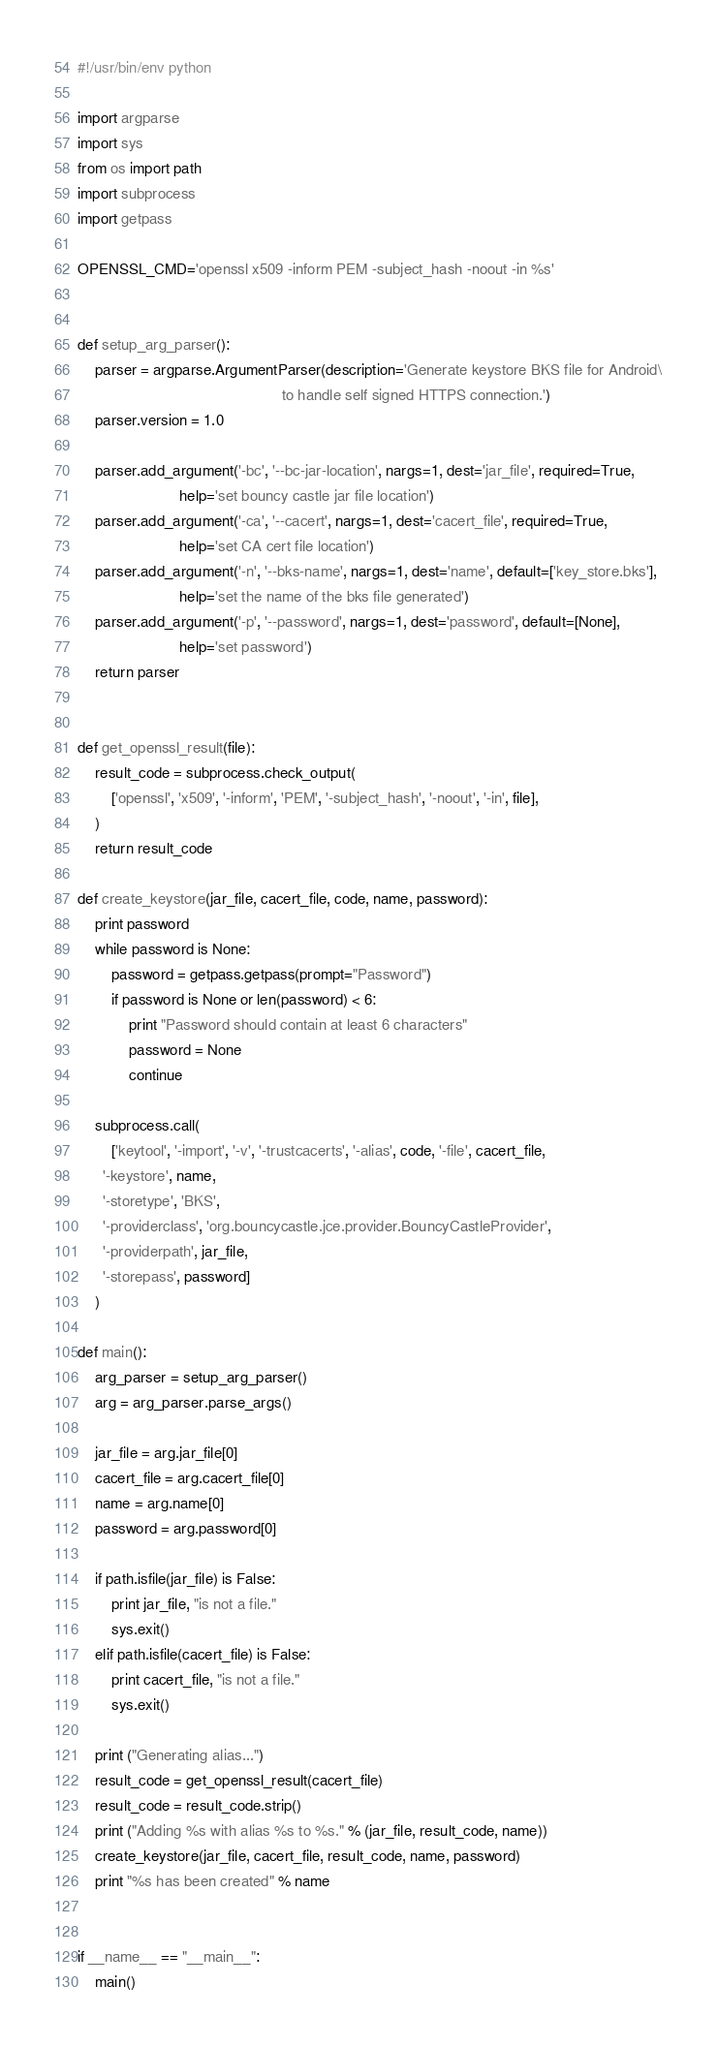Convert code to text. <code><loc_0><loc_0><loc_500><loc_500><_Python_>#!/usr/bin/env python

import argparse
import sys
from os import path
import subprocess
import getpass

OPENSSL_CMD='openssl x509 -inform PEM -subject_hash -noout -in %s'


def setup_arg_parser():
    parser = argparse.ArgumentParser(description='Generate keystore BKS file for Android\
                                                to handle self signed HTTPS connection.')
    parser.version = 1.0

    parser.add_argument('-bc', '--bc-jar-location', nargs=1, dest='jar_file', required=True,
                        help='set bouncy castle jar file location')
    parser.add_argument('-ca', '--cacert', nargs=1, dest='cacert_file', required=True,
                        help='set CA cert file location')
    parser.add_argument('-n', '--bks-name', nargs=1, dest='name', default=['key_store.bks'],
                        help='set the name of the bks file generated')
    parser.add_argument('-p', '--password', nargs=1, dest='password', default=[None],
                        help='set password')
    return parser


def get_openssl_result(file):
    result_code = subprocess.check_output(
        ['openssl', 'x509', '-inform', 'PEM', '-subject_hash', '-noout', '-in', file],
    )
    return result_code

def create_keystore(jar_file, cacert_file, code, name, password):
    print password
    while password is None:
        password = getpass.getpass(prompt="Password")
        if password is None or len(password) < 6:
            print "Password should contain at least 6 characters"
            password = None
            continue

    subprocess.call(
        ['keytool', '-import', '-v', '-trustcacerts', '-alias', code, '-file', cacert_file,
      '-keystore', name,
      '-storetype', 'BKS',
      '-providerclass', 'org.bouncycastle.jce.provider.BouncyCastleProvider',
      '-providerpath', jar_file,
      '-storepass', password]
    )

def main():
    arg_parser = setup_arg_parser()
    arg = arg_parser.parse_args()

    jar_file = arg.jar_file[0]
    cacert_file = arg.cacert_file[0]
    name = arg.name[0]
    password = arg.password[0]

    if path.isfile(jar_file) is False:
        print jar_file, "is not a file."
        sys.exit()
    elif path.isfile(cacert_file) is False:
        print cacert_file, "is not a file."
        sys.exit()

    print ("Generating alias...")
    result_code = get_openssl_result(cacert_file)
    result_code = result_code.strip()
    print ("Adding %s with alias %s to %s." % (jar_file, result_code, name))
    create_keystore(jar_file, cacert_file, result_code, name, password)
    print "%s has been created" % name


if __name__ == "__main__":
    main()

</code> 